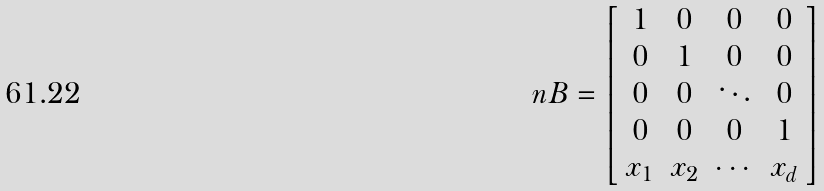<formula> <loc_0><loc_0><loc_500><loc_500>\ n B = \left [ \begin{array} { c c c c } 1 & 0 & 0 & 0 \\ 0 & 1 & 0 & 0 \\ 0 & 0 & \ddots & 0 \\ 0 & 0 & 0 & 1 \\ x _ { 1 } & x _ { 2 } & \cdots & x _ { d } \end{array} \right ]</formula> 